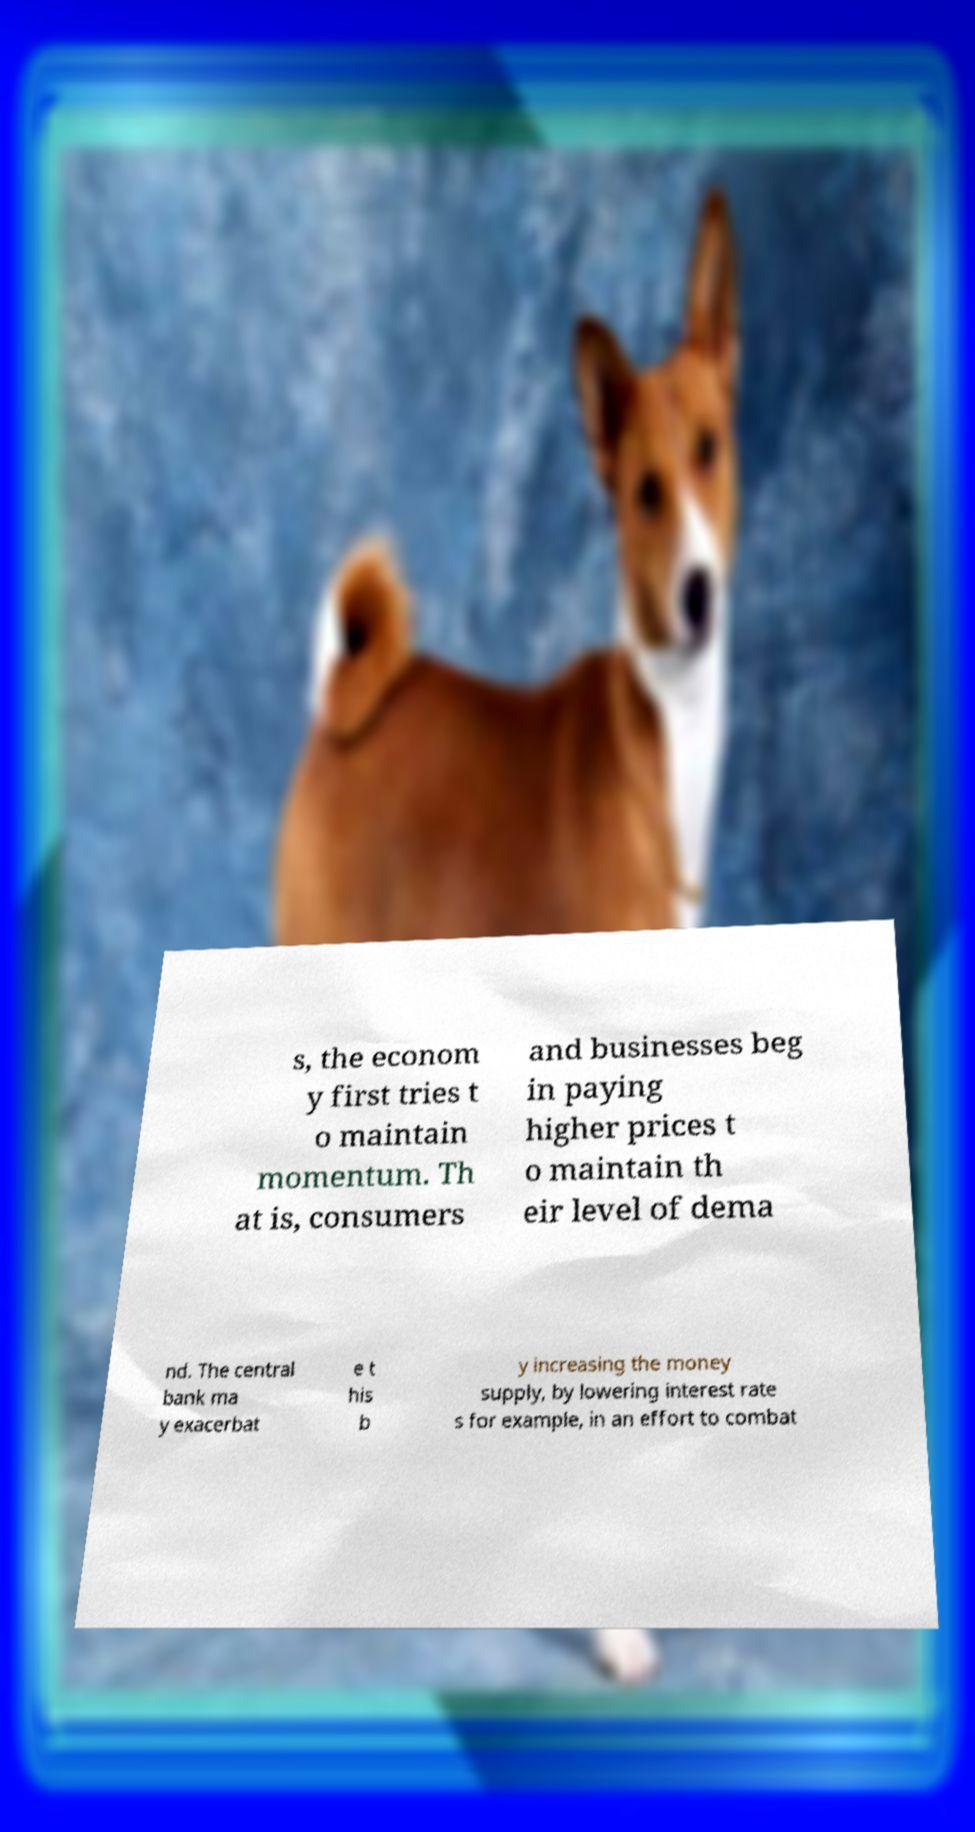What messages or text are displayed in this image? I need them in a readable, typed format. s, the econom y first tries t o maintain momentum. Th at is, consumers and businesses beg in paying higher prices t o maintain th eir level of dema nd. The central bank ma y exacerbat e t his b y increasing the money supply, by lowering interest rate s for example, in an effort to combat 